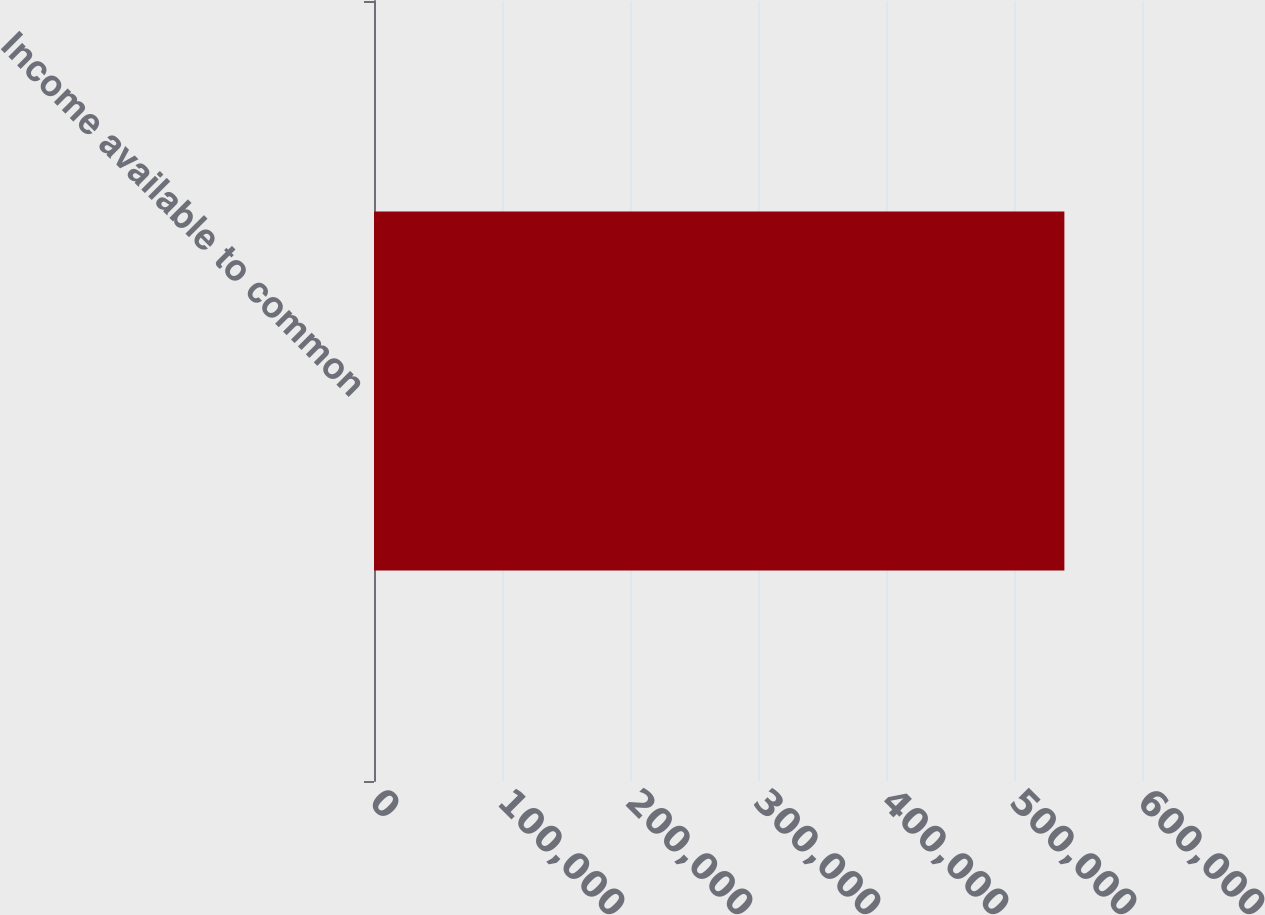<chart> <loc_0><loc_0><loc_500><loc_500><bar_chart><fcel>Income available to common<nl><fcel>539362<nl></chart> 